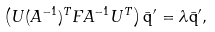<formula> <loc_0><loc_0><loc_500><loc_500>\left ( { U } ( { A } ^ { - 1 } ) ^ { T } { F } { A } ^ { - 1 } { U } ^ { T } \right ) \bar { \mathsf q } ^ { \prime } = { \lambda } \bar { \mathsf q } ^ { \prime } ,</formula> 